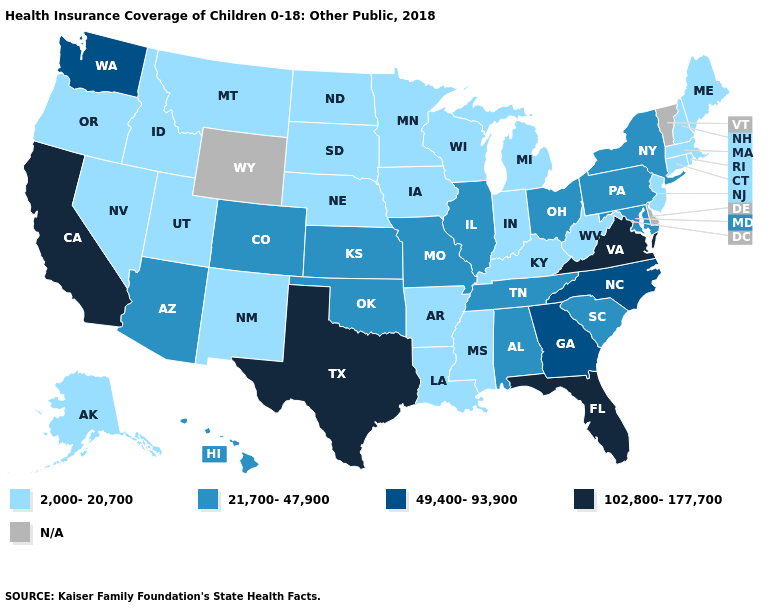Does the map have missing data?
Quick response, please. Yes. What is the lowest value in the USA?
Keep it brief. 2,000-20,700. Name the states that have a value in the range 2,000-20,700?
Keep it brief. Alaska, Arkansas, Connecticut, Idaho, Indiana, Iowa, Kentucky, Louisiana, Maine, Massachusetts, Michigan, Minnesota, Mississippi, Montana, Nebraska, Nevada, New Hampshire, New Jersey, New Mexico, North Dakota, Oregon, Rhode Island, South Dakota, Utah, West Virginia, Wisconsin. Which states have the highest value in the USA?
Give a very brief answer. California, Florida, Texas, Virginia. What is the value of West Virginia?
Be succinct. 2,000-20,700. Name the states that have a value in the range N/A?
Keep it brief. Delaware, Vermont, Wyoming. What is the lowest value in states that border Idaho?
Give a very brief answer. 2,000-20,700. Does Alabama have the lowest value in the USA?
Be succinct. No. What is the value of California?
Be succinct. 102,800-177,700. Name the states that have a value in the range 21,700-47,900?
Give a very brief answer. Alabama, Arizona, Colorado, Hawaii, Illinois, Kansas, Maryland, Missouri, New York, Ohio, Oklahoma, Pennsylvania, South Carolina, Tennessee. Which states hav the highest value in the Northeast?
Answer briefly. New York, Pennsylvania. Which states hav the highest value in the West?
Quick response, please. California. What is the highest value in the USA?
Keep it brief. 102,800-177,700. Name the states that have a value in the range N/A?
Answer briefly. Delaware, Vermont, Wyoming. 